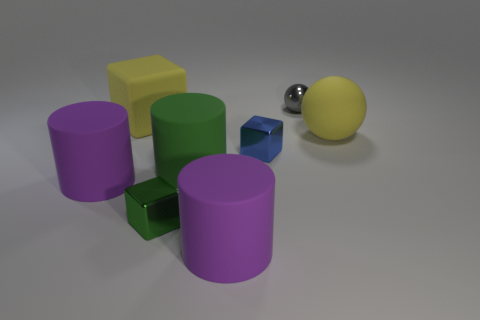What material is the thing that is the same color as the large ball?
Keep it short and to the point. Rubber. Is the number of blue blocks greater than the number of large purple cylinders?
Keep it short and to the point. No. Do the blue metallic block and the thing that is to the right of the gray metal thing have the same size?
Make the answer very short. No. What color is the metallic ball on the right side of the green metal block?
Keep it short and to the point. Gray. What number of blue objects are either tiny metal things or matte cylinders?
Provide a short and direct response. 1. The small sphere has what color?
Your answer should be compact. Gray. Is there any other thing that has the same material as the green cylinder?
Your answer should be compact. Yes. Is the number of tiny gray shiny objects that are on the left side of the blue cube less than the number of blue shiny things that are on the left side of the gray object?
Your response must be concise. Yes. What shape is the small thing that is in front of the big yellow rubber block and on the right side of the small green metallic cube?
Offer a very short reply. Cube. What number of purple matte things have the same shape as the small gray metal object?
Your answer should be very brief. 0. 